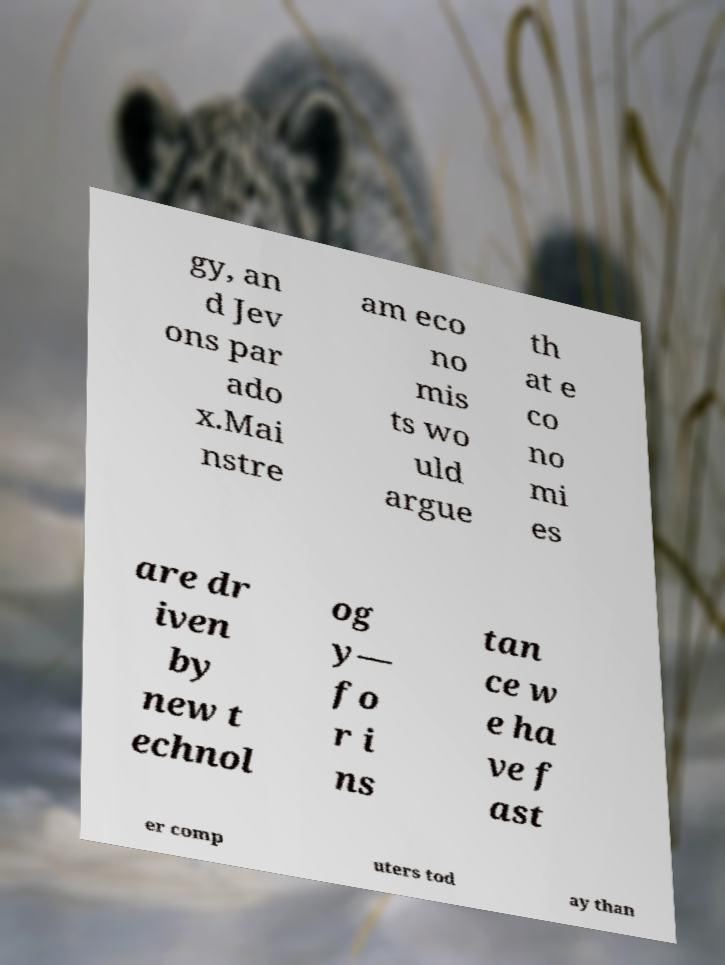Please identify and transcribe the text found in this image. gy, an d Jev ons par ado x.Mai nstre am eco no mis ts wo uld argue th at e co no mi es are dr iven by new t echnol og y— fo r i ns tan ce w e ha ve f ast er comp uters tod ay than 